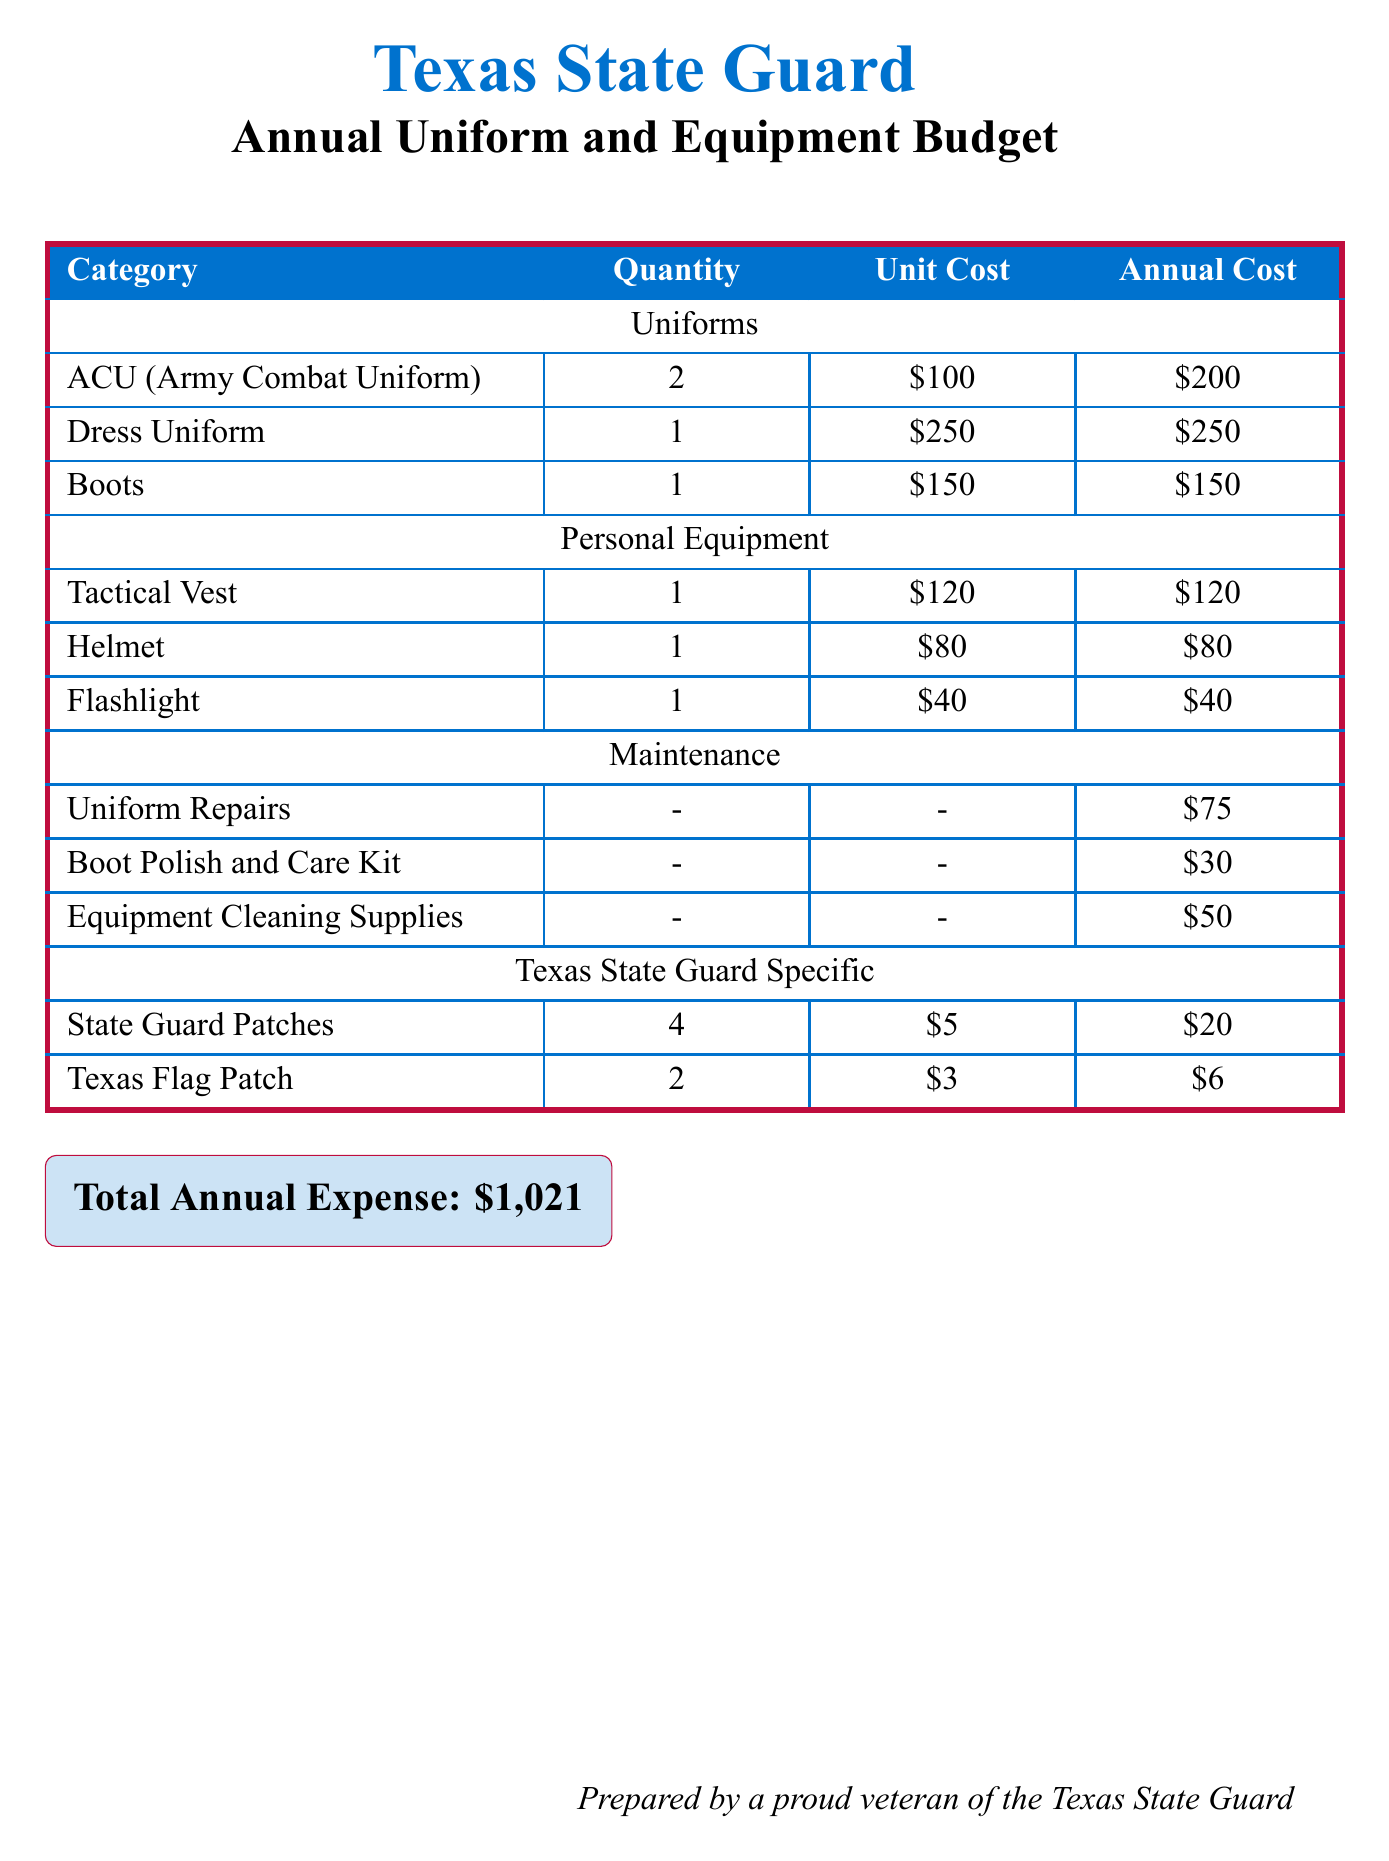What is the total annual expense? The total annual expense is provided at the bottom of the document and represents the cumulative cost of maintaining uniforms and equipment.
Answer: $1,021 How many Army Combat Uniforms are included? The quantity of Army Combat Uniforms is specified in the document under the uniforms category.
Answer: 2 What is the unit cost of the Dress Uniform? The unit cost of each Dress Uniform is listed in the budget table under the uniforms category.
Answer: $250 What is the cost for uniform repairs? The document specifies the maintenance cost for uniform repairs as part of the overall budget.
Answer: $75 How many State Guard Patches are required? The document states the required quantity of State Guard Patches under the Texas State Guard Specific category.
Answer: 4 What is the total cost for Personal Equipment? The total cost for Personal Equipment can be found by summing the annual costs listed under that category.
Answer: $240 What maintenance item costs $30? The document includes a maintenance item that costs $30, specified in the maintenance section.
Answer: Boot Polish and Care Kit Which item has the lowest cost? The document lists all item costs, making it possible to identify the lowest cost item included in the budget.
Answer: $3 (Texas Flag Patch) 